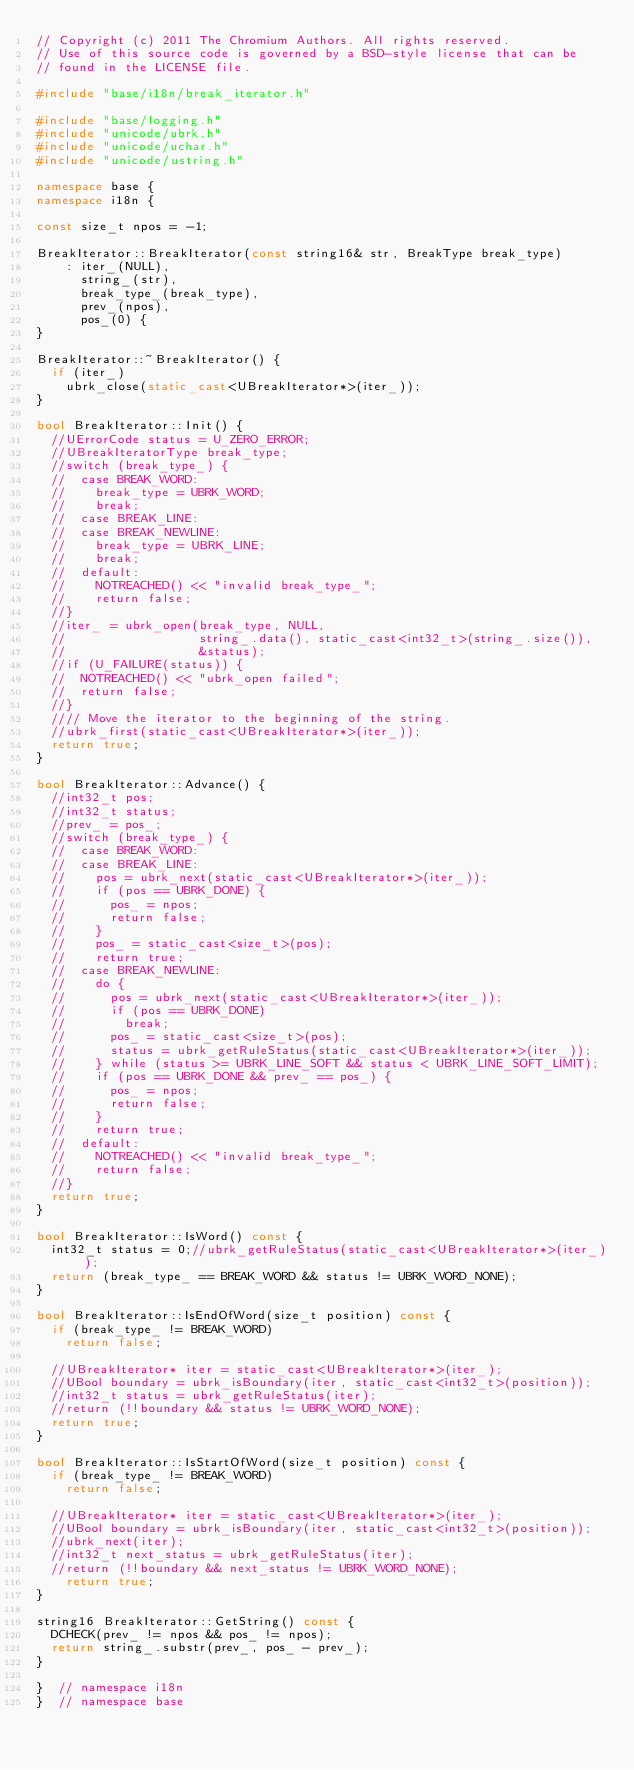<code> <loc_0><loc_0><loc_500><loc_500><_C++_>// Copyright (c) 2011 The Chromium Authors. All rights reserved.
// Use of this source code is governed by a BSD-style license that can be
// found in the LICENSE file.

#include "base/i18n/break_iterator.h"

#include "base/logging.h"
#include "unicode/ubrk.h"
#include "unicode/uchar.h"
#include "unicode/ustring.h"

namespace base {
namespace i18n {

const size_t npos = -1;

BreakIterator::BreakIterator(const string16& str, BreakType break_type)
    : iter_(NULL),
      string_(str),
      break_type_(break_type),
      prev_(npos),
      pos_(0) {
}

BreakIterator::~BreakIterator() {
  if (iter_)
    ubrk_close(static_cast<UBreakIterator*>(iter_));
}

bool BreakIterator::Init() {
  //UErrorCode status = U_ZERO_ERROR;
  //UBreakIteratorType break_type;
  //switch (break_type_) {
  //  case BREAK_WORD:
  //    break_type = UBRK_WORD;
  //    break;
  //  case BREAK_LINE:
  //  case BREAK_NEWLINE:
  //    break_type = UBRK_LINE;
  //    break;
  //  default:
  //    NOTREACHED() << "invalid break_type_";
  //    return false;
  //}
  //iter_ = ubrk_open(break_type, NULL,
  //                  string_.data(), static_cast<int32_t>(string_.size()),
  //                  &status);
  //if (U_FAILURE(status)) {
  //  NOTREACHED() << "ubrk_open failed";
  //  return false;
  //}
  //// Move the iterator to the beginning of the string.
  //ubrk_first(static_cast<UBreakIterator*>(iter_));
  return true;
}

bool BreakIterator::Advance() {
  //int32_t pos;
  //int32_t status;
  //prev_ = pos_;
  //switch (break_type_) {
  //  case BREAK_WORD:
  //  case BREAK_LINE:
  //    pos = ubrk_next(static_cast<UBreakIterator*>(iter_));
  //    if (pos == UBRK_DONE) {
  //      pos_ = npos;
  //      return false;
  //    }
  //    pos_ = static_cast<size_t>(pos);
  //    return true;
  //  case BREAK_NEWLINE:
  //    do {
  //      pos = ubrk_next(static_cast<UBreakIterator*>(iter_));
  //      if (pos == UBRK_DONE)
  //        break;
  //      pos_ = static_cast<size_t>(pos);
  //      status = ubrk_getRuleStatus(static_cast<UBreakIterator*>(iter_));
  //    } while (status >= UBRK_LINE_SOFT && status < UBRK_LINE_SOFT_LIMIT);
  //    if (pos == UBRK_DONE && prev_ == pos_) {
  //      pos_ = npos;
  //      return false;
  //    }
  //    return true;
  //  default:
  //    NOTREACHED() << "invalid break_type_";
  //    return false;
  //}
	return true;
}

bool BreakIterator::IsWord() const {
  int32_t status = 0;//ubrk_getRuleStatus(static_cast<UBreakIterator*>(iter_));
  return (break_type_ == BREAK_WORD && status != UBRK_WORD_NONE);
}

bool BreakIterator::IsEndOfWord(size_t position) const {
  if (break_type_ != BREAK_WORD)
    return false;

  //UBreakIterator* iter = static_cast<UBreakIterator*>(iter_);
  //UBool boundary = ubrk_isBoundary(iter, static_cast<int32_t>(position));
  //int32_t status = ubrk_getRuleStatus(iter);
  //return (!!boundary && status != UBRK_WORD_NONE);
  return true;
}

bool BreakIterator::IsStartOfWord(size_t position) const {
  if (break_type_ != BREAK_WORD)
    return false;

  //UBreakIterator* iter = static_cast<UBreakIterator*>(iter_);
  //UBool boundary = ubrk_isBoundary(iter, static_cast<int32_t>(position));
  //ubrk_next(iter);
  //int32_t next_status = ubrk_getRuleStatus(iter);
  //return (!!boundary && next_status != UBRK_WORD_NONE);
    return true;
}

string16 BreakIterator::GetString() const {
  DCHECK(prev_ != npos && pos_ != npos);
  return string_.substr(prev_, pos_ - prev_);
}

}  // namespace i18n
}  // namespace base
</code> 